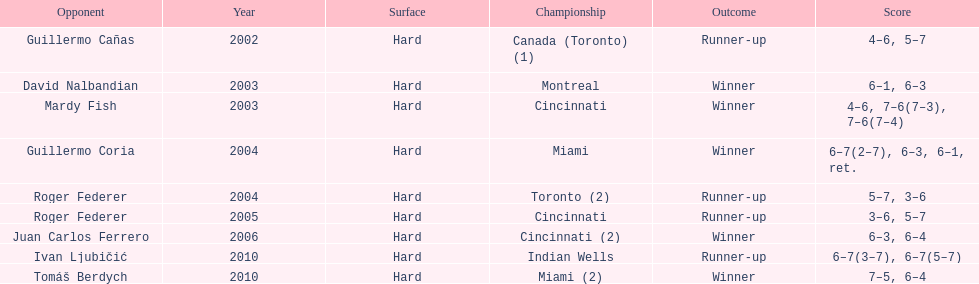How many championships occurred in toronto or montreal? 3. 